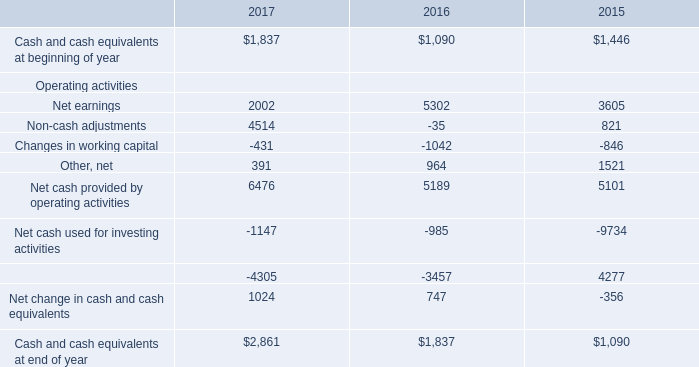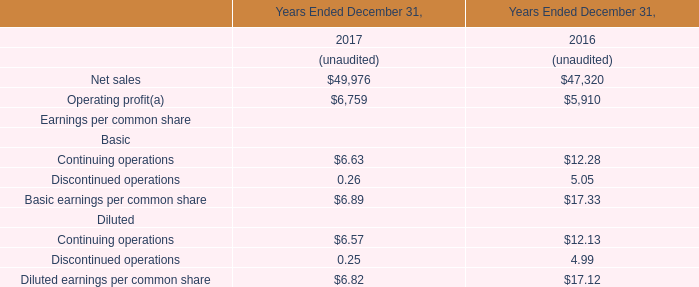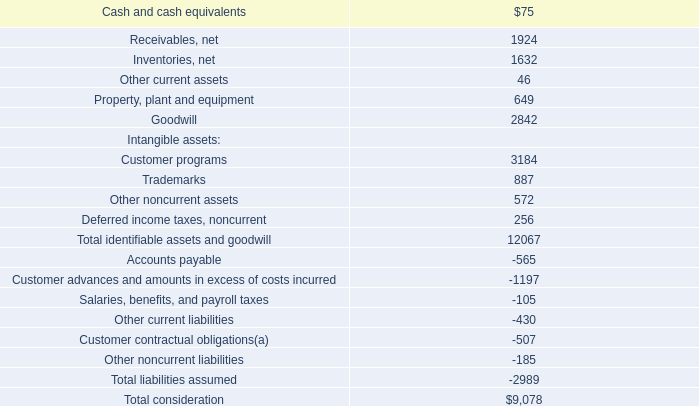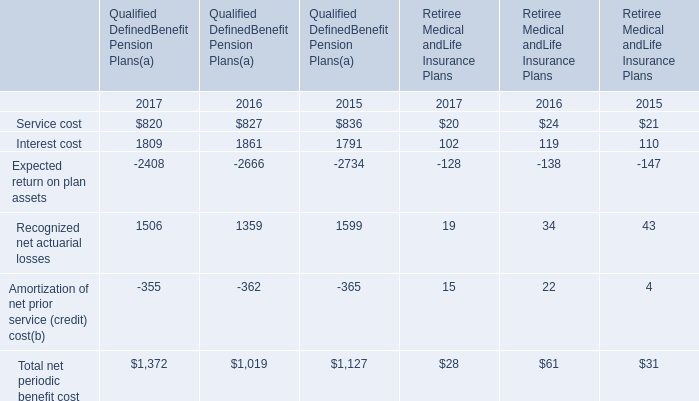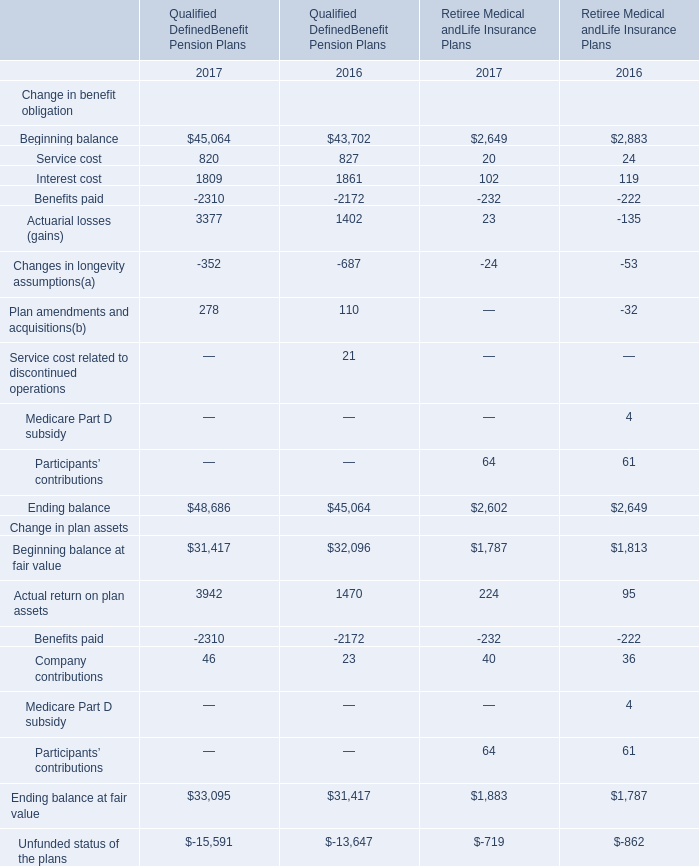what's the total amount of Benefits paid of Qualified DefinedBenefit Pension Plans 2016, and Cash and cash equivalents at beginning of year of 2016 ? 
Computations: (2172.0 + 1090.0)
Answer: 3262.0. 